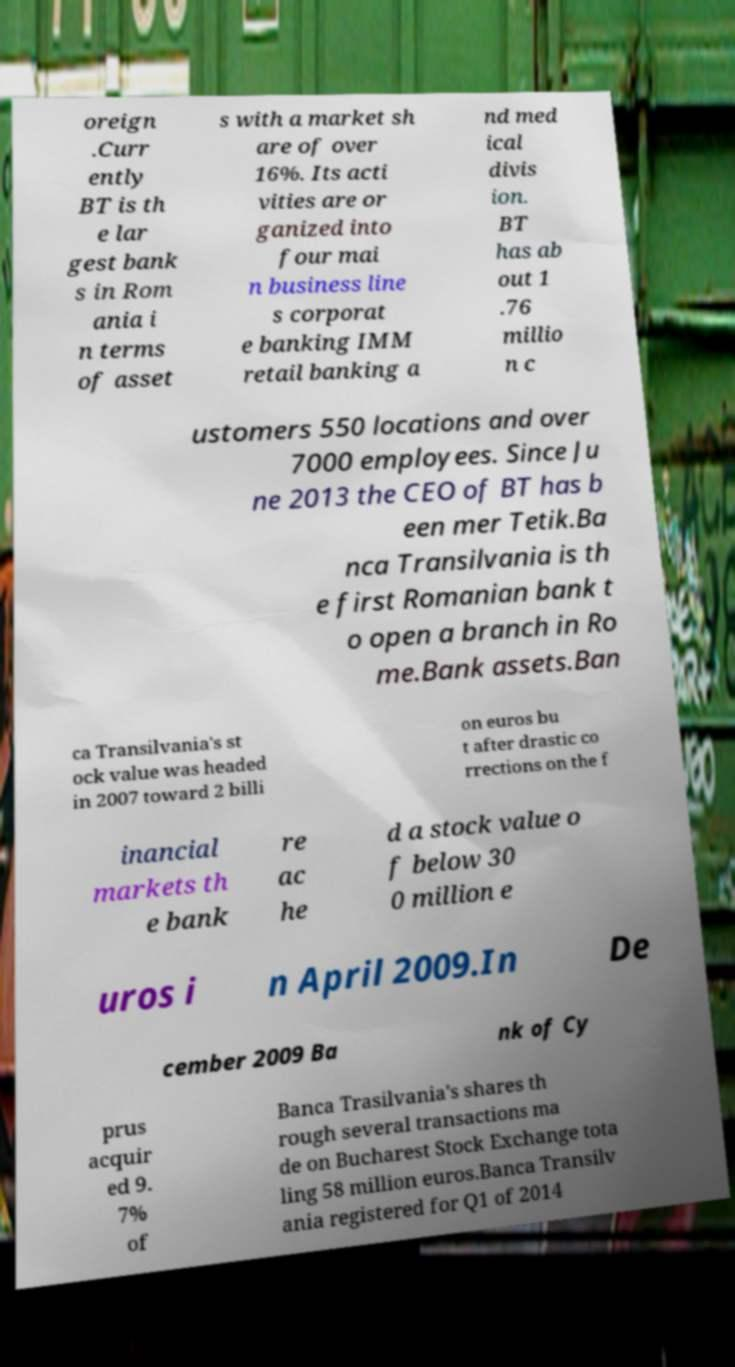Please read and relay the text visible in this image. What does it say? oreign .Curr ently BT is th e lar gest bank s in Rom ania i n terms of asset s with a market sh are of over 16%. Its acti vities are or ganized into four mai n business line s corporat e banking IMM retail banking a nd med ical divis ion. BT has ab out 1 .76 millio n c ustomers 550 locations and over 7000 employees. Since Ju ne 2013 the CEO of BT has b een mer Tetik.Ba nca Transilvania is th e first Romanian bank t o open a branch in Ro me.Bank assets.Ban ca Transilvania's st ock value was headed in 2007 toward 2 billi on euros bu t after drastic co rrections on the f inancial markets th e bank re ac he d a stock value o f below 30 0 million e uros i n April 2009.In De cember 2009 Ba nk of Cy prus acquir ed 9. 7% of Banca Trasilvania's shares th rough several transactions ma de on Bucharest Stock Exchange tota ling 58 million euros.Banca Transilv ania registered for Q1 of 2014 